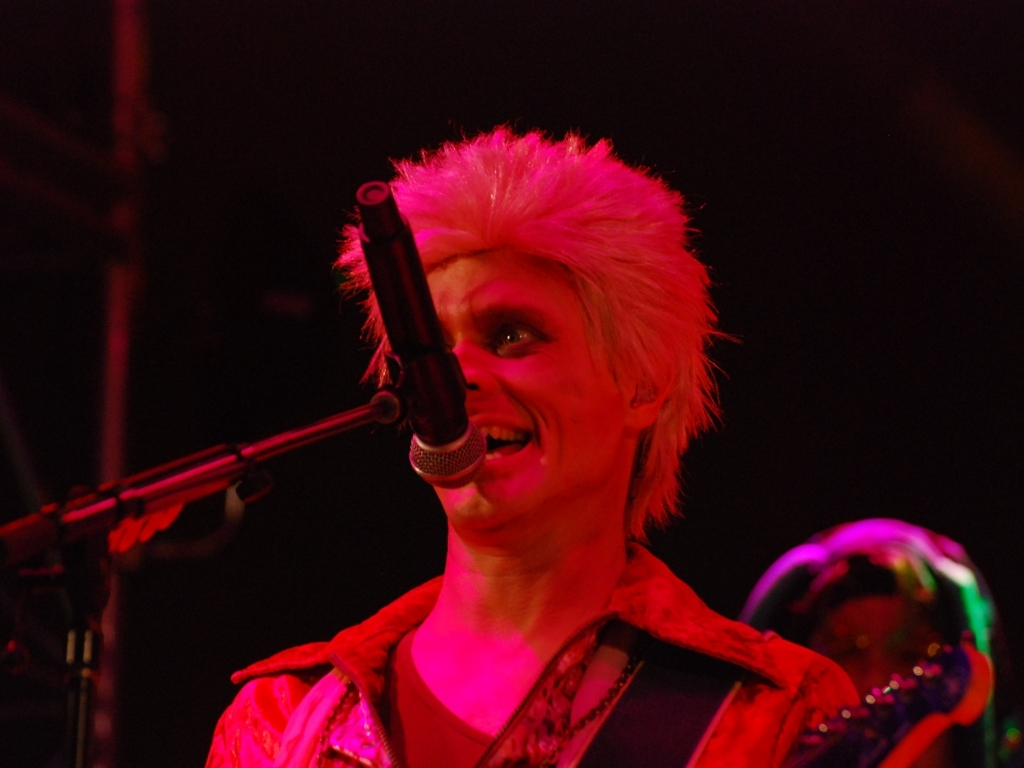What emotions does the image evoke and how does the lighting contribute to that? The image evokes a sense of excitement and intensity. The face is illuminated with a reddish hue, casting dramatic shadows that enhance the emotional expression, creating an atmosphere of passion and vitality typical of live performances. 